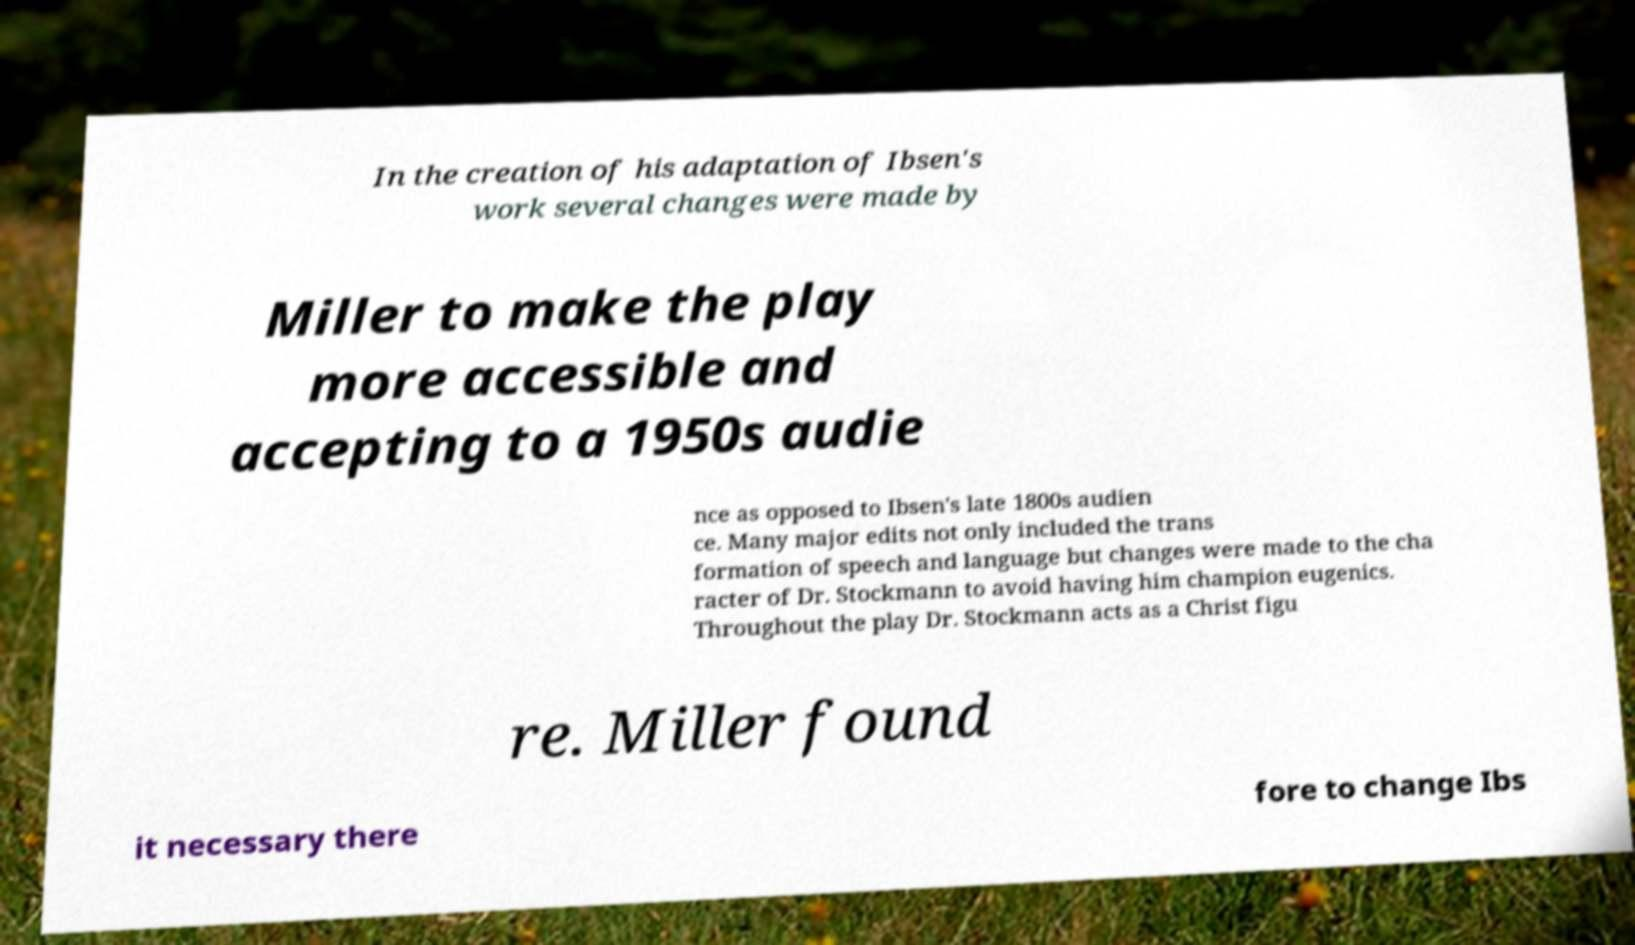Please read and relay the text visible in this image. What does it say? In the creation of his adaptation of Ibsen's work several changes were made by Miller to make the play more accessible and accepting to a 1950s audie nce as opposed to Ibsen's late 1800s audien ce. Many major edits not only included the trans formation of speech and language but changes were made to the cha racter of Dr. Stockmann to avoid having him champion eugenics. Throughout the play Dr. Stockmann acts as a Christ figu re. Miller found it necessary there fore to change Ibs 